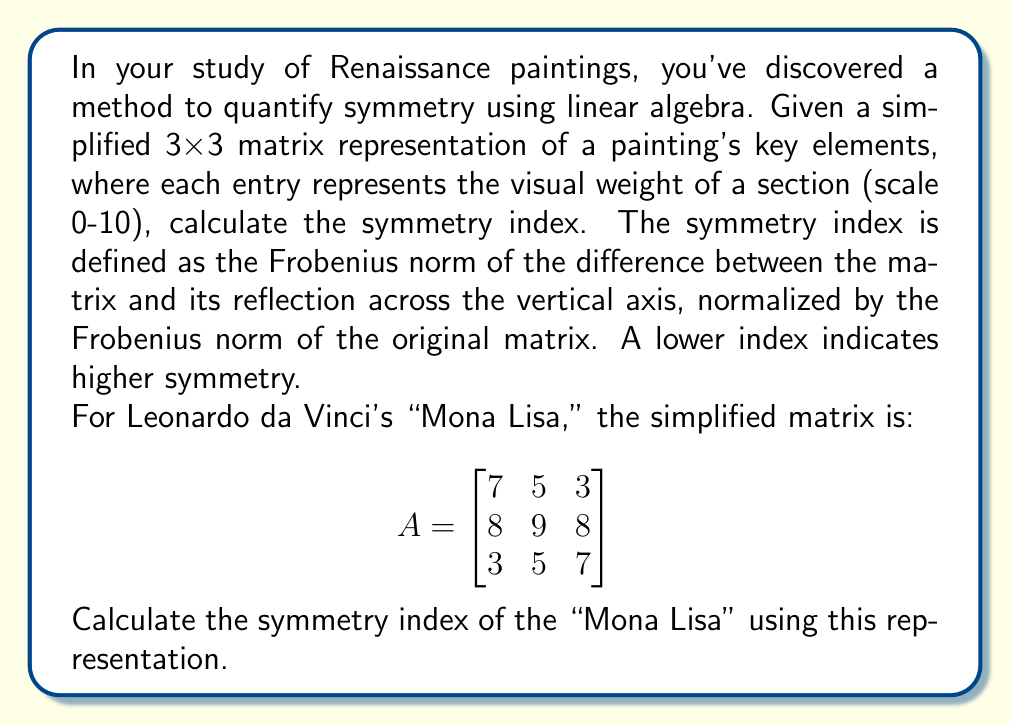Show me your answer to this math problem. To solve this problem, we'll follow these steps:

1) First, we need to create the reflection of matrix A across the vertical axis. Let's call this matrix B:

$$
B = \begin{bmatrix}
3 & 5 & 7 \\
8 & 9 & 8 \\
7 & 5 & 3
\end{bmatrix}
$$

2) Now, we calculate the difference matrix C = A - B:

$$
C = A - B = \begin{bmatrix}
7-3 & 5-5 & 3-7 \\
8-8 & 9-9 & 8-8 \\
3-7 & 5-5 & 7-3
\end{bmatrix} = \begin{bmatrix}
4 & 0 & -4 \\
0 & 0 & 0 \\
-4 & 0 & 4
\end{bmatrix}
$$

3) The Frobenius norm of a matrix is defined as the square root of the sum of the squares of its elements. For matrix C:

$$\|C\|_F = \sqrt{4^2 + 0^2 + (-4)^2 + 0^2 + 0^2 + 0^2 + (-4)^2 + 0^2 + 4^2} = \sqrt{64} = 8$$

4) Now we calculate the Frobenius norm of the original matrix A:

$$\|A\|_F = \sqrt{7^2 + 5^2 + 3^2 + 8^2 + 9^2 + 8^2 + 3^2 + 5^2 + 7^2} = \sqrt{335} \approx 18.30$$

5) The symmetry index is the ratio of these norms:

$$\text{Symmetry Index} = \frac{\|C\|_F}{\|A\|_F} = \frac{8}{\sqrt{335}} \approx 0.4372$$

This value, being less than 1 and relatively close to 0, indicates a fairly high degree of symmetry in the "Mona Lisa," which aligns with the balanced composition often noted by art historians.
Answer: The symmetry index of the "Mona Lisa" based on the given matrix representation is approximately 0.4372. 